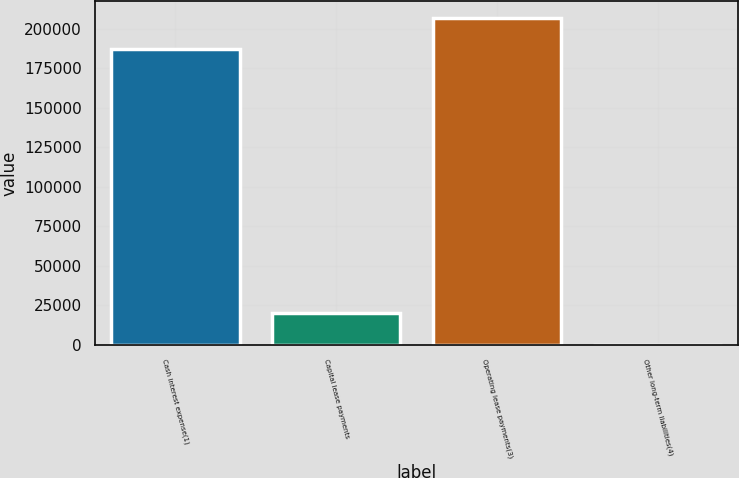Convert chart. <chart><loc_0><loc_0><loc_500><loc_500><bar_chart><fcel>Cash interest expense(1)<fcel>Capital lease payments<fcel>Operating lease payments(3)<fcel>Other long-term liabilities(4)<nl><fcel>187000<fcel>20078.9<fcel>206912<fcel>167<nl></chart> 